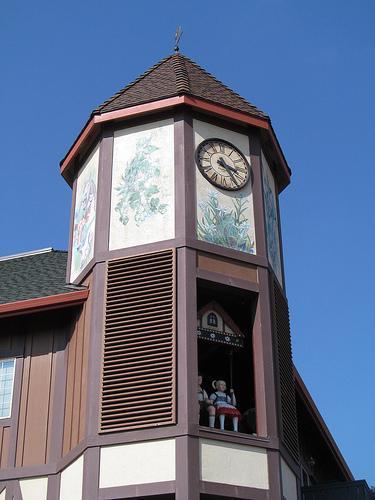How many clocks are there?
Give a very brief answer. 1. 